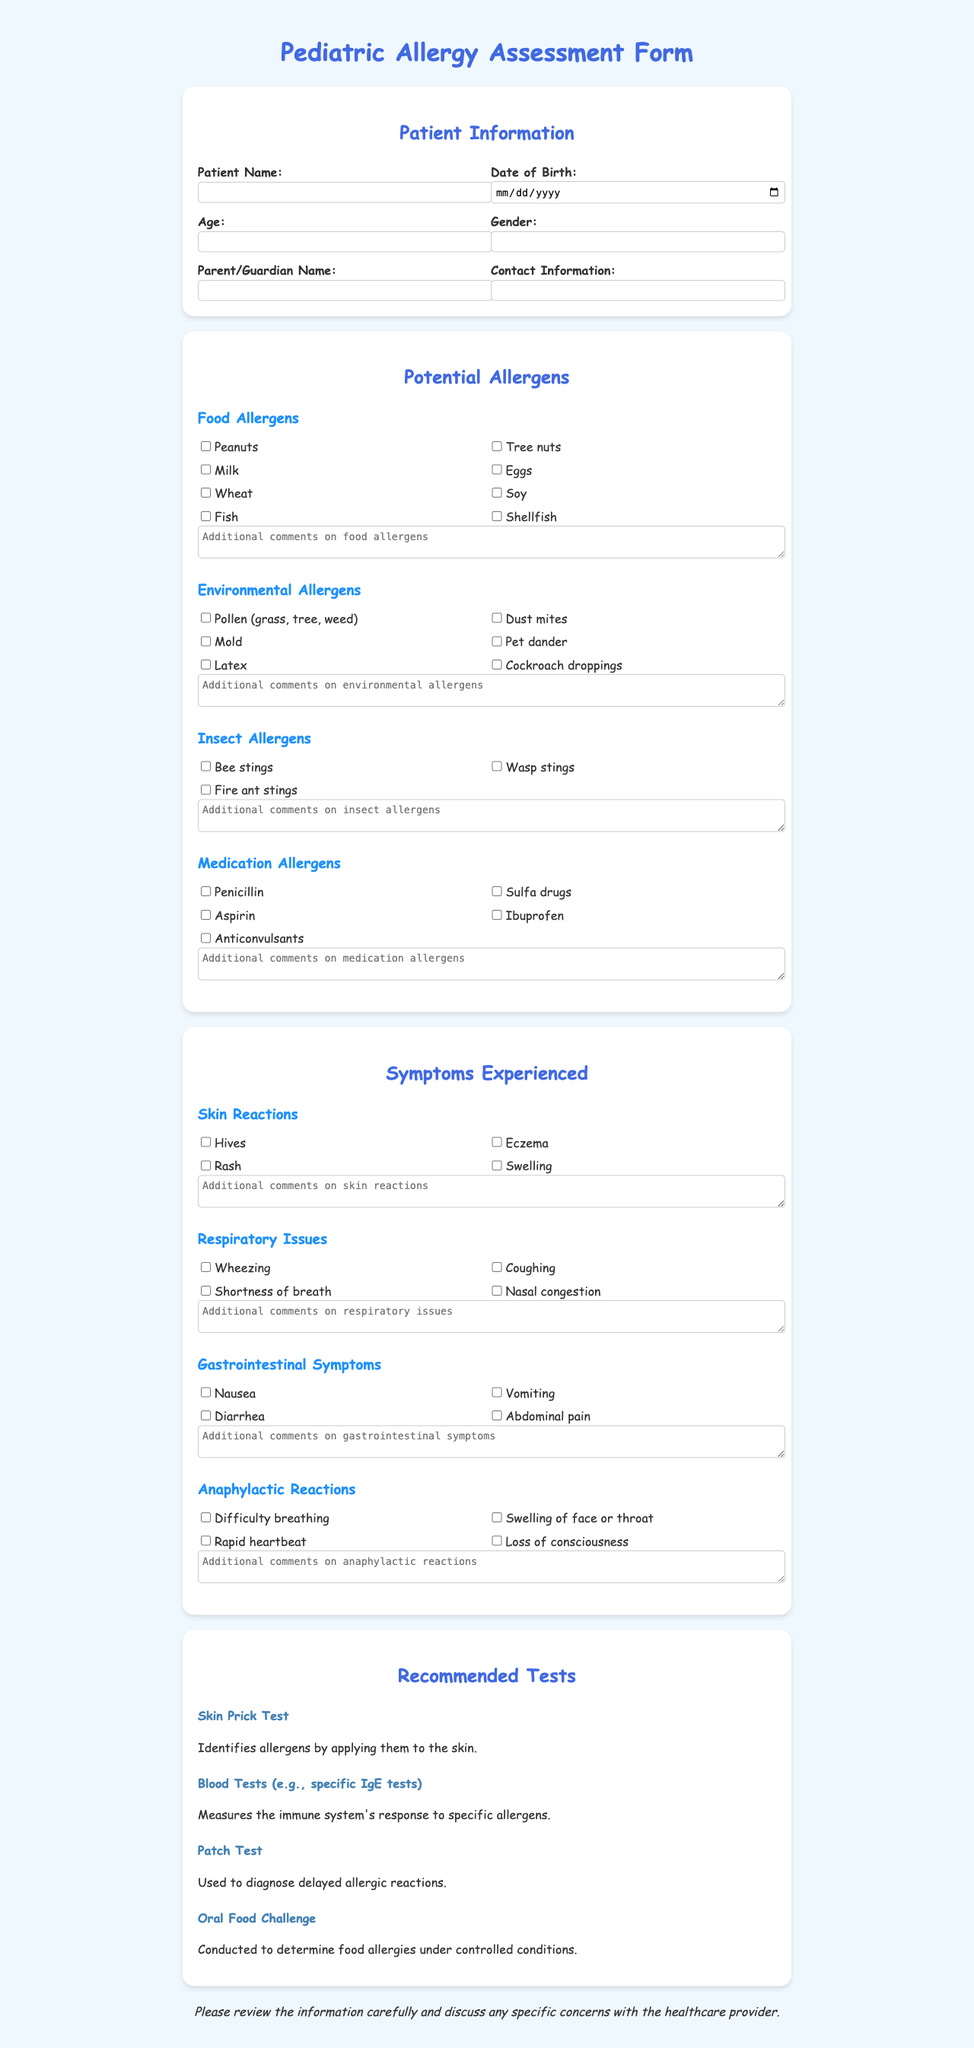what is the title of the document? The title of the document is stated prominently at the top of the page.
Answer: Pediatric Allergy Assessment Form how many food allergens are listed? The document provides a specific section detailing food allergens and counts them.
Answer: 8 what are the potential environmental allergens? This question is meant to consolidate the listed allergens in a specific category.
Answer: Pollen (grass, tree, weed), Dust mites, Mold, Pet dander, Latex, Cockroach droppings which symptom indicates anaphylactic reaction? Anaphylactic reactions comprise a specific set of symptoms outlined in the document.
Answer: Difficulty breathing what is one recommended test for allergies? The document includes various tests recommended for allergy assessment, listing several options.
Answer: Skin Prick Test how is the patient's contact information gathered? The document specifies the sections where personal details, including contact information, are recorded.
Answer: In the Patient Information section what type of symptoms are categorized under gastrointestinal symptoms? This enables identification of specific symptoms that fall under a particular category.
Answer: Nausea, Vomiting, Diarrhea, Abdominal pain what additional comments can be made regarding food allergens? The document includes textarea sections to elaborate on the listed allergens.
Answer: Additional comments on food allergens 